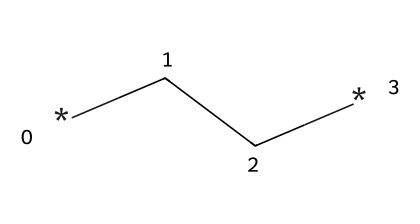What is the molecular formula of polyethylene? Polyethylene is made up of repeating units of ethylene (C2H4). Therefore, its molecular formula can be represented as (C2H4)n.
Answer: (C2H4)n How many carbon atoms are present in the simplest repeating unit of polyethylene? The SMILES notation "CC" indicates that there are 2 carbon atoms in the simplest repeating unit of polyethylene.
Answer: 2 Is polyethylene a thermoplastic or thermosetting polymer? Polyethylene is classified as a thermoplastic polymer because it becomes pliable upon heating and hardens upon cooling, without undergoing any chemical change.
Answer: thermoplastic What type of bonds are present in the structure of polyethylene? The structure shows carbon-carbon single bonds (C-C) and carbon-hydrogen bonds (C-H), characterizing the molecule as having covalent bonds.
Answer: covalent bonds What is the degree of polymerization in polyethylene? The degree of polymerization (n) in polyethylene can vary significantly, often reaching thousands depending on how the polymer is processed and formed.
Answer: thousands Does polyethylene dissolve in water? Polyethylene is classified as a non-electrolyte and is insoluble in water, due to the hydrophobic nature of its hydrocarbon structure.
Answer: insoluble 